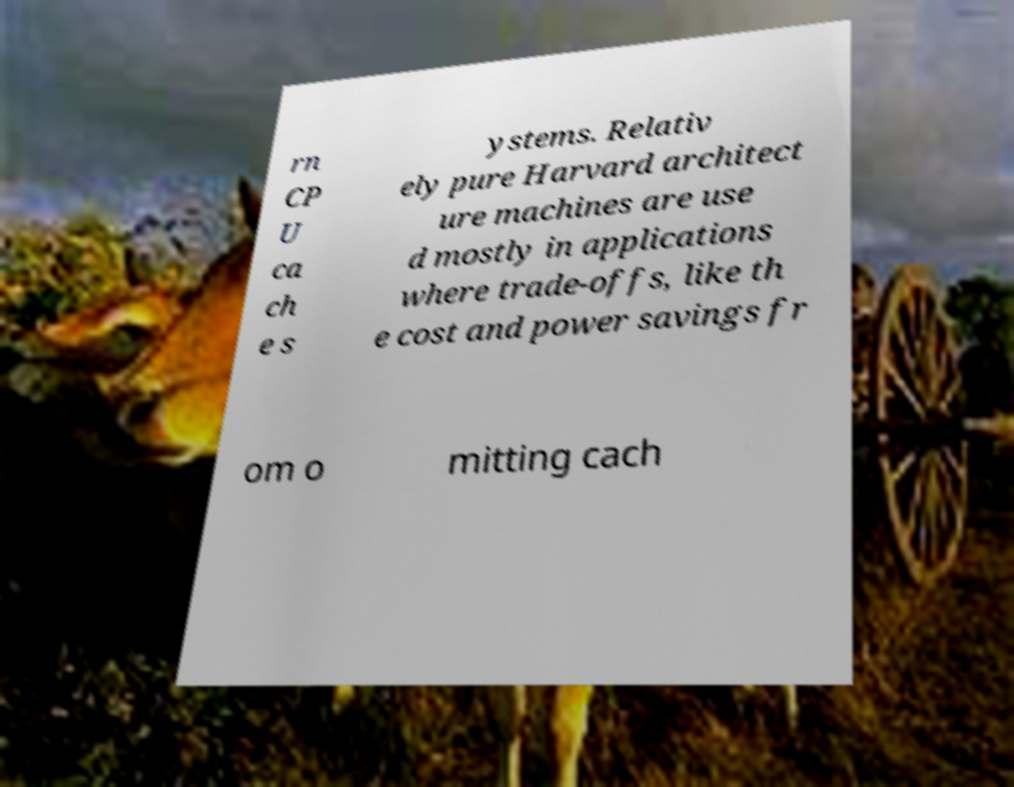Please read and relay the text visible in this image. What does it say? rn CP U ca ch e s ystems. Relativ ely pure Harvard architect ure machines are use d mostly in applications where trade-offs, like th e cost and power savings fr om o mitting cach 